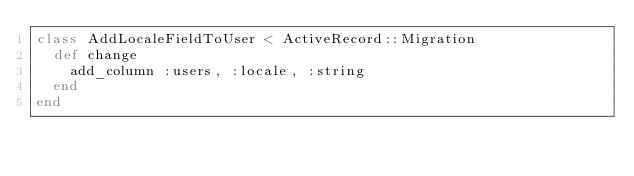Convert code to text. <code><loc_0><loc_0><loc_500><loc_500><_Ruby_>class AddLocaleFieldToUser < ActiveRecord::Migration
  def change
    add_column :users, :locale, :string
  end
end
</code> 